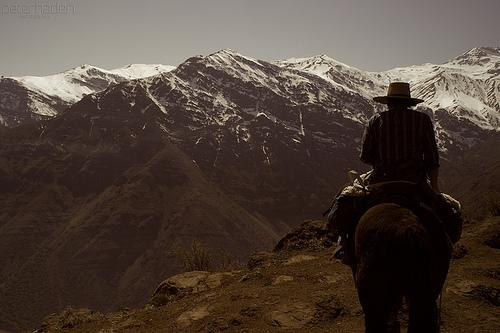Provide a brief overview of the prominent subject in the photograph. The image shows a man wearing a cowboy hat and riding a horse in the mountainous terrain. What is the dominant activity depicted in the image? A man on horseback is admiring the snow-capped mountains in the distance. State the main activity portrayed in the image and point out the notable elements present. A guy riding a horse near a cliff is surrounded by rocky terrain, grass, and snow-capped mountains. In one sentence, describe the core event captured in the image. A man in a checkered shirt is on horseback, gazing at the snow-covered mountains nearby. Describe the key subject in the photo and what they seem to be engaged in. A person wearing a ten-gallon hat is on horseback, examining the stunning mountains in the distance. Mention the central figure in the scene and their action. A cowboy is riding a horse near the edge of a cliff overlooking the mountains. Give a concise description of the central theme depicted in the picture. A cowboy on horseback is observing the beautiful snowy mountains from a cliff. Identify the most noticeable subject in the image, and mention their actions. A cowboy is riding a horse and gazing at the beautiful, snow-covered mountains nearby. Summarize the primary event portrayed in the image and provide a few details. A man on a horse is looking at the snow-capped mountains, with rocks and grass around them. Briefly describe the primary figure and their activity in the scene. A man on horseback, wearing a hat and checkered shirt, is admiring the mountains from a cliff's edge. 